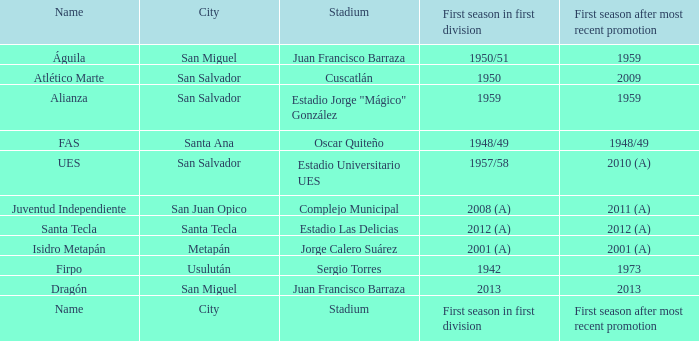Which city is Alianza? San Salvador. 